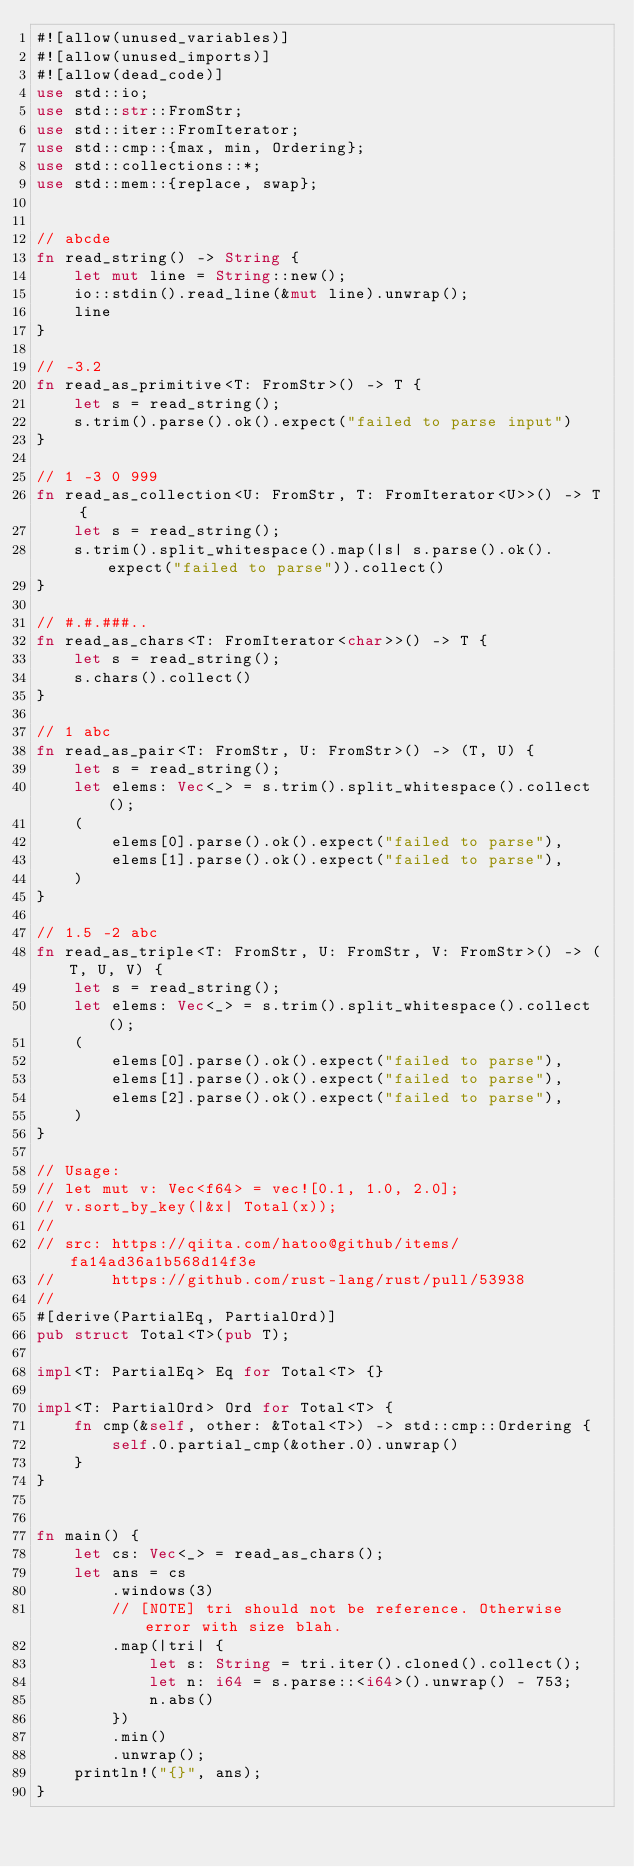<code> <loc_0><loc_0><loc_500><loc_500><_Rust_>#![allow(unused_variables)]
#![allow(unused_imports)]
#![allow(dead_code)]
use std::io;
use std::str::FromStr;
use std::iter::FromIterator;
use std::cmp::{max, min, Ordering};
use std::collections::*;
use std::mem::{replace, swap};


// abcde
fn read_string() -> String {
    let mut line = String::new();
    io::stdin().read_line(&mut line).unwrap();
    line
}

// -3.2
fn read_as_primitive<T: FromStr>() -> T {
    let s = read_string();
    s.trim().parse().ok().expect("failed to parse input")
}

// 1 -3 0 999
fn read_as_collection<U: FromStr, T: FromIterator<U>>() -> T {
    let s = read_string();
    s.trim().split_whitespace().map(|s| s.parse().ok().expect("failed to parse")).collect()
}

// #.#.###..
fn read_as_chars<T: FromIterator<char>>() -> T {
    let s = read_string();
    s.chars().collect()
}

// 1 abc
fn read_as_pair<T: FromStr, U: FromStr>() -> (T, U) {
    let s = read_string();
    let elems: Vec<_> = s.trim().split_whitespace().collect();
    (
        elems[0].parse().ok().expect("failed to parse"),
        elems[1].parse().ok().expect("failed to parse"),
    )
}

// 1.5 -2 abc
fn read_as_triple<T: FromStr, U: FromStr, V: FromStr>() -> (T, U, V) {
    let s = read_string();
    let elems: Vec<_> = s.trim().split_whitespace().collect();
    (
        elems[0].parse().ok().expect("failed to parse"),
        elems[1].parse().ok().expect("failed to parse"),
        elems[2].parse().ok().expect("failed to parse"),
    )
}

// Usage:
// let mut v: Vec<f64> = vec![0.1, 1.0, 2.0];
// v.sort_by_key(|&x| Total(x));
// 
// src: https://qiita.com/hatoo@github/items/fa14ad36a1b568d14f3e
//      https://github.com/rust-lang/rust/pull/53938
//
#[derive(PartialEq, PartialOrd)]
pub struct Total<T>(pub T);

impl<T: PartialEq> Eq for Total<T> {}

impl<T: PartialOrd> Ord for Total<T> {
    fn cmp(&self, other: &Total<T>) -> std::cmp::Ordering {
        self.0.partial_cmp(&other.0).unwrap()
    }
}


fn main() {
    let cs: Vec<_> = read_as_chars();
    let ans = cs
        .windows(3)
        // [NOTE] tri should not be reference. Otherwise error with size blah.
        .map(|tri| {
            let s: String = tri.iter().cloned().collect();
            let n: i64 = s.parse::<i64>().unwrap() - 753;
            n.abs()
        })
        .min()
        .unwrap();
    println!("{}", ans);
}</code> 